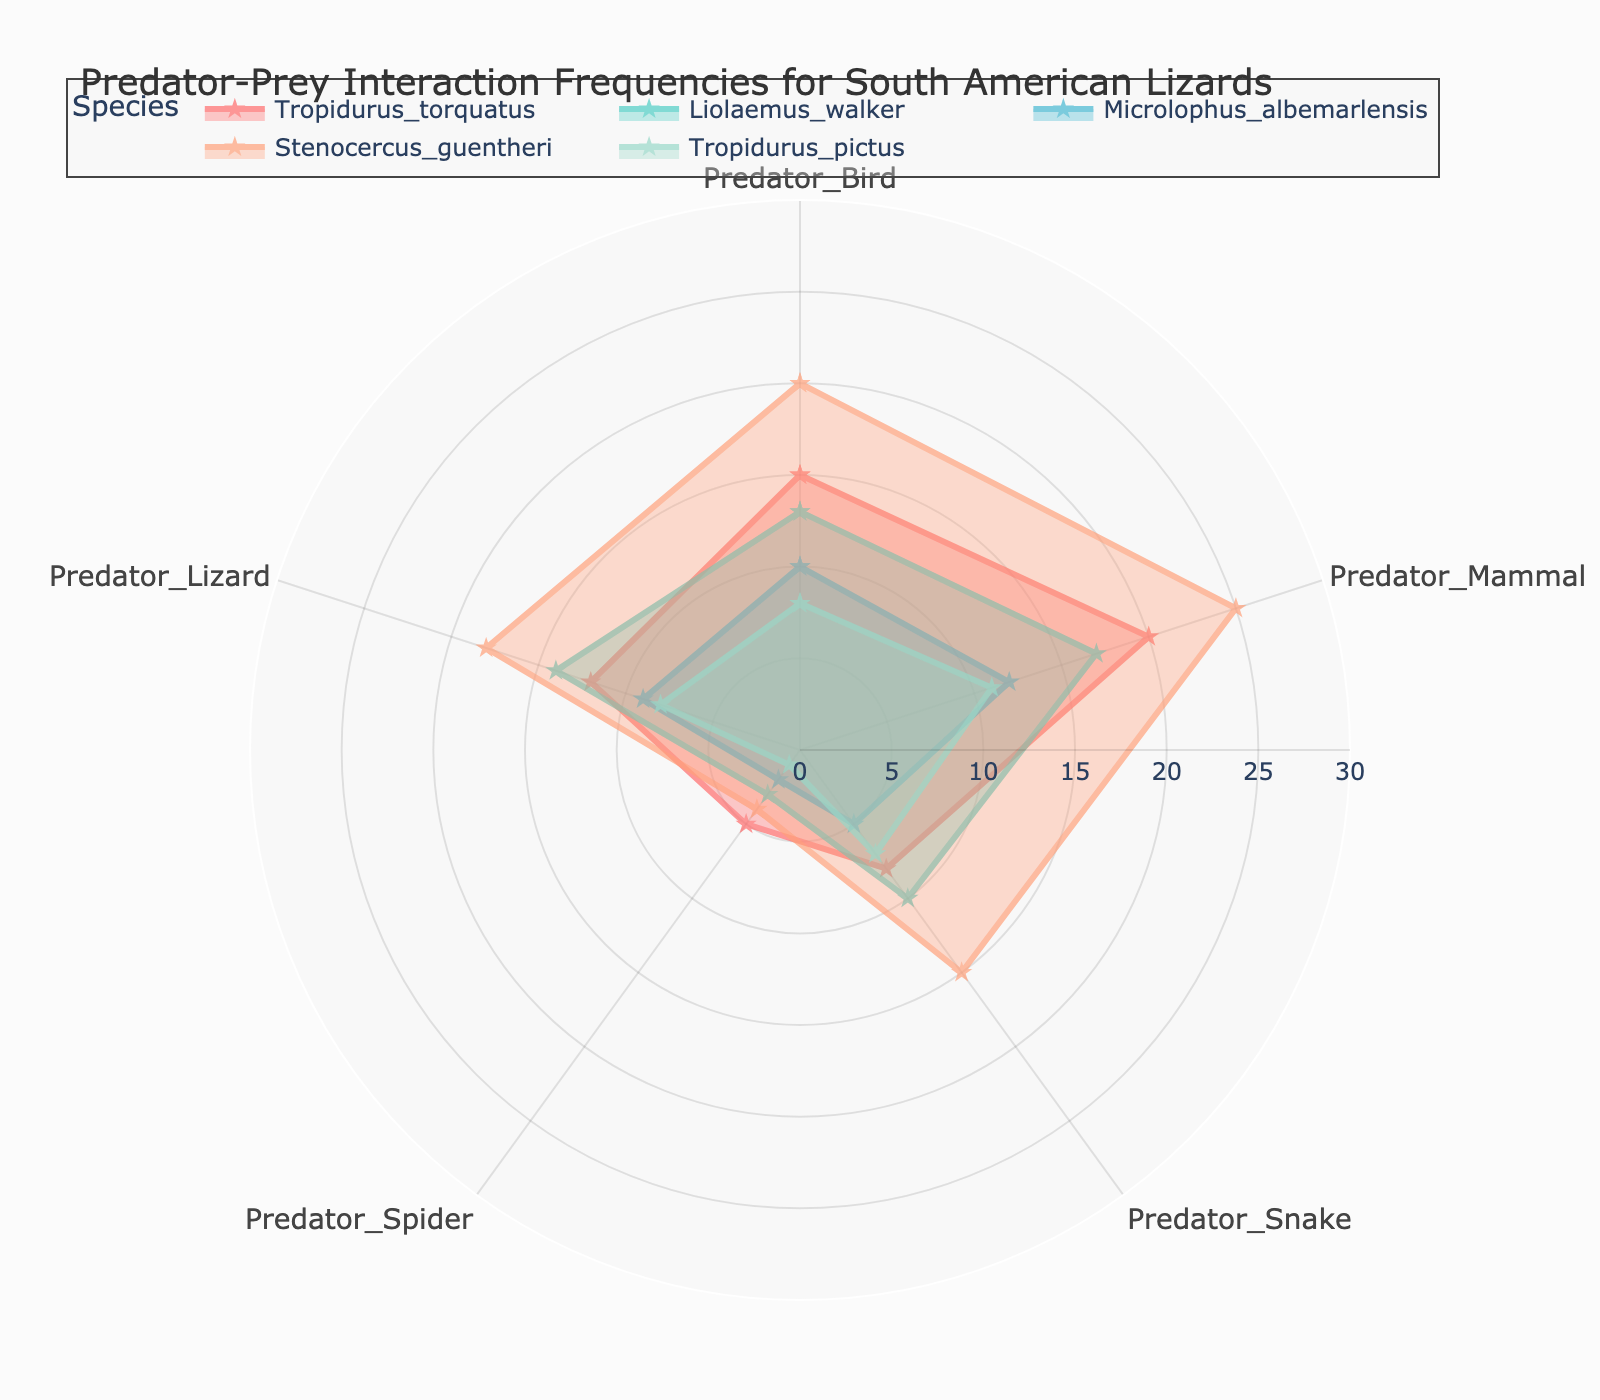What is the highest frequency of interaction with predator birds for any species? For each species, look at the data points corresponding to "Predator_Bird." The species with the highest frequency is Stenocercus_guentheri with a value of 20 interactions.
Answer: Stenocercus_guentheri, 20 Which species has the least interaction frequency with predator spiders? Compare the interaction frequency with predator spiders for each species. Tropidurus_pictus shows the least interaction with a value of 1.
Answer: Tropidurus_pictus, 1 How many data points are plotted for each species? A radar chart typically has one data point for each category. There are 5 categories (Predator_Bird, Predator_Mammal, Predator_Snake, Predator_Spider, Predator_Lizard) along with an additional point to close the polygon, so each species has 6 data points plotted.
Answer: 6 Which species has the highest total interaction frequency across all predator types? Sum the frequencies for each predator type for each species. Stenocercus_guentheri has the highest total with 82 interactions (20+25+15+4+18).
Answer: Stenocercus_guentheri In what range do most of the interaction frequencies fall for predator snakes? Observing the radar chart, the frequencies of interaction with predator snakes for all species range from 5 to 15.
Answer: 5 to 15 Which two species have the closest interaction frequencies for predator mammals, and what are those frequencies? Look at the frequencies for predator mammals. Liolaemus_walker and Microlophus_albemarlensis have the closest interaction frequencies with values of 17 and 12 respectively.
Answer: Liolaemus_walker, Microlophus_albemarlensis, 17 and 12 How does the interaction with predator lizards compare between Tropidurus_pictus and Liolaemus_walker? Tropidurus_pictus and Liolaemus_walker have interaction frequencies of 8 and 14 respectively for predator lizards. Liolaemus_walker has a higher frequency.
Answer: Liolaemus_walker > Tropidurus_pictus What average frequency do Tropidurus_torquatus and Stenocercus_guentheri have across all predator types? Calculate the average for both species. Tropidurus_torquatus: (15+20+8+5+12)/5 = 12, Stenocercus_guentheri: (20+25+15+4+18)/5 = 16.4
Answer: Tropidurus_torquatus: 12, Stenocercus_guentheri: 16.4 